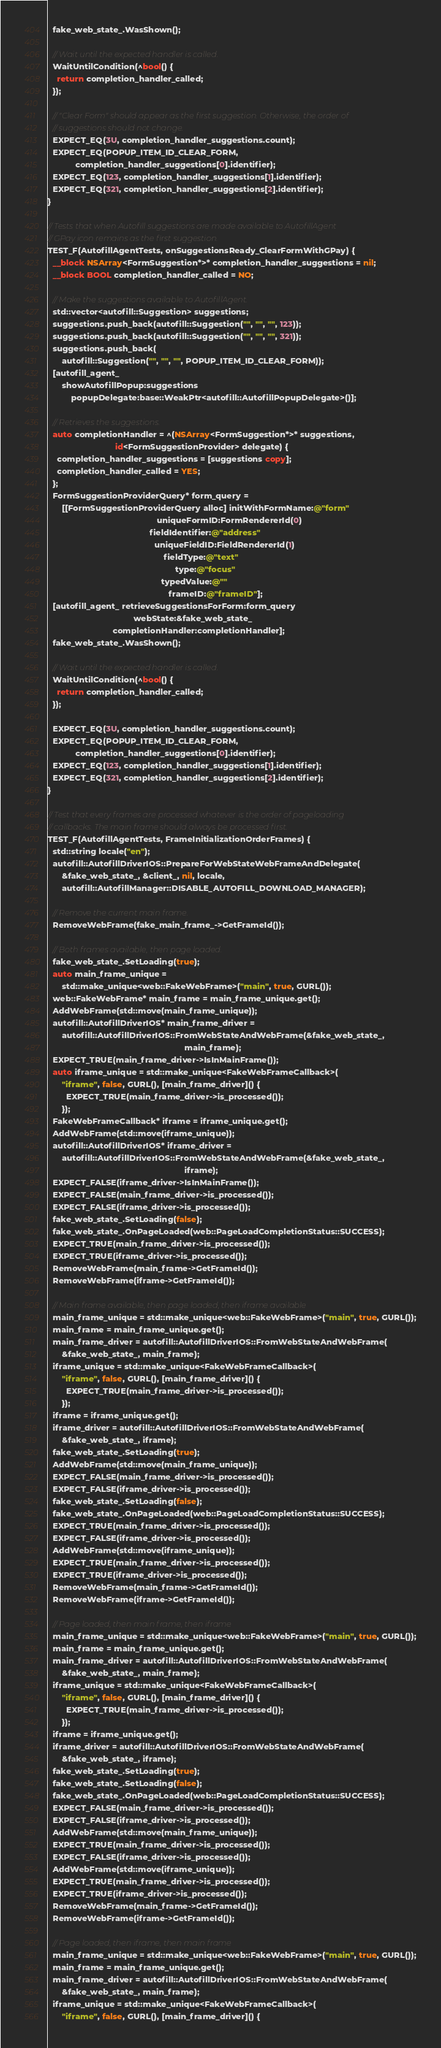<code> <loc_0><loc_0><loc_500><loc_500><_ObjectiveC_>  fake_web_state_.WasShown();

  // Wait until the expected handler is called.
  WaitUntilCondition(^bool() {
    return completion_handler_called;
  });

  // "Clear Form" should appear as the first suggestion. Otherwise, the order of
  // suggestions should not change.
  EXPECT_EQ(3U, completion_handler_suggestions.count);
  EXPECT_EQ(POPUP_ITEM_ID_CLEAR_FORM,
            completion_handler_suggestions[0].identifier);
  EXPECT_EQ(123, completion_handler_suggestions[1].identifier);
  EXPECT_EQ(321, completion_handler_suggestions[2].identifier);
}

// Tests that when Autofill suggestions are made available to AutofillAgent
// GPay icon remains as the first suggestion.
TEST_F(AutofillAgentTests, onSuggestionsReady_ClearFormWithGPay) {
  __block NSArray<FormSuggestion*>* completion_handler_suggestions = nil;
  __block BOOL completion_handler_called = NO;

  // Make the suggestions available to AutofillAgent.
  std::vector<autofill::Suggestion> suggestions;
  suggestions.push_back(autofill::Suggestion("", "", "", 123));
  suggestions.push_back(autofill::Suggestion("", "", "", 321));
  suggestions.push_back(
      autofill::Suggestion("", "", "", POPUP_ITEM_ID_CLEAR_FORM));
  [autofill_agent_
      showAutofillPopup:suggestions
          popupDelegate:base::WeakPtr<autofill::AutofillPopupDelegate>()];

  // Retrieves the suggestions.
  auto completionHandler = ^(NSArray<FormSuggestion*>* suggestions,
                             id<FormSuggestionProvider> delegate) {
    completion_handler_suggestions = [suggestions copy];
    completion_handler_called = YES;
  };
  FormSuggestionProviderQuery* form_query =
      [[FormSuggestionProviderQuery alloc] initWithFormName:@"form"
                                               uniqueFormID:FormRendererId(0)
                                            fieldIdentifier:@"address"
                                              uniqueFieldID:FieldRendererId(1)
                                                  fieldType:@"text"
                                                       type:@"focus"
                                                 typedValue:@""
                                                    frameID:@"frameID"];
  [autofill_agent_ retrieveSuggestionsForForm:form_query
                                     webState:&fake_web_state_
                            completionHandler:completionHandler];
  fake_web_state_.WasShown();

  // Wait until the expected handler is called.
  WaitUntilCondition(^bool() {
    return completion_handler_called;
  });

  EXPECT_EQ(3U, completion_handler_suggestions.count);
  EXPECT_EQ(POPUP_ITEM_ID_CLEAR_FORM,
            completion_handler_suggestions[0].identifier);
  EXPECT_EQ(123, completion_handler_suggestions[1].identifier);
  EXPECT_EQ(321, completion_handler_suggestions[2].identifier);
}

// Test that every frames are processed whatever is the order of pageloading
// callbacks. The main frame should always be processed first.
TEST_F(AutofillAgentTests, FrameInitializationOrderFrames) {
  std::string locale("en");
  autofill::AutofillDriverIOS::PrepareForWebStateWebFrameAndDelegate(
      &fake_web_state_, &client_, nil, locale,
      autofill::AutofillManager::DISABLE_AUTOFILL_DOWNLOAD_MANAGER);

  // Remove the current main frame.
  RemoveWebFrame(fake_main_frame_->GetFrameId());

  // Both frames available, then page loaded.
  fake_web_state_.SetLoading(true);
  auto main_frame_unique =
      std::make_unique<web::FakeWebFrame>("main", true, GURL());
  web::FakeWebFrame* main_frame = main_frame_unique.get();
  AddWebFrame(std::move(main_frame_unique));
  autofill::AutofillDriverIOS* main_frame_driver =
      autofill::AutofillDriverIOS::FromWebStateAndWebFrame(&fake_web_state_,
                                                           main_frame);
  EXPECT_TRUE(main_frame_driver->IsInMainFrame());
  auto iframe_unique = std::make_unique<FakeWebFrameCallback>(
      "iframe", false, GURL(), [main_frame_driver]() {
        EXPECT_TRUE(main_frame_driver->is_processed());
      });
  FakeWebFrameCallback* iframe = iframe_unique.get();
  AddWebFrame(std::move(iframe_unique));
  autofill::AutofillDriverIOS* iframe_driver =
      autofill::AutofillDriverIOS::FromWebStateAndWebFrame(&fake_web_state_,
                                                           iframe);
  EXPECT_FALSE(iframe_driver->IsInMainFrame());
  EXPECT_FALSE(main_frame_driver->is_processed());
  EXPECT_FALSE(iframe_driver->is_processed());
  fake_web_state_.SetLoading(false);
  fake_web_state_.OnPageLoaded(web::PageLoadCompletionStatus::SUCCESS);
  EXPECT_TRUE(main_frame_driver->is_processed());
  EXPECT_TRUE(iframe_driver->is_processed());
  RemoveWebFrame(main_frame->GetFrameId());
  RemoveWebFrame(iframe->GetFrameId());

  // Main frame available, then page loaded, then iframe available
  main_frame_unique = std::make_unique<web::FakeWebFrame>("main", true, GURL());
  main_frame = main_frame_unique.get();
  main_frame_driver = autofill::AutofillDriverIOS::FromWebStateAndWebFrame(
      &fake_web_state_, main_frame);
  iframe_unique = std::make_unique<FakeWebFrameCallback>(
      "iframe", false, GURL(), [main_frame_driver]() {
        EXPECT_TRUE(main_frame_driver->is_processed());
      });
  iframe = iframe_unique.get();
  iframe_driver = autofill::AutofillDriverIOS::FromWebStateAndWebFrame(
      &fake_web_state_, iframe);
  fake_web_state_.SetLoading(true);
  AddWebFrame(std::move(main_frame_unique));
  EXPECT_FALSE(main_frame_driver->is_processed());
  EXPECT_FALSE(iframe_driver->is_processed());
  fake_web_state_.SetLoading(false);
  fake_web_state_.OnPageLoaded(web::PageLoadCompletionStatus::SUCCESS);
  EXPECT_TRUE(main_frame_driver->is_processed());
  EXPECT_FALSE(iframe_driver->is_processed());
  AddWebFrame(std::move(iframe_unique));
  EXPECT_TRUE(main_frame_driver->is_processed());
  EXPECT_TRUE(iframe_driver->is_processed());
  RemoveWebFrame(main_frame->GetFrameId());
  RemoveWebFrame(iframe->GetFrameId());

  // Page loaded, then main frame, then iframe
  main_frame_unique = std::make_unique<web::FakeWebFrame>("main", true, GURL());
  main_frame = main_frame_unique.get();
  main_frame_driver = autofill::AutofillDriverIOS::FromWebStateAndWebFrame(
      &fake_web_state_, main_frame);
  iframe_unique = std::make_unique<FakeWebFrameCallback>(
      "iframe", false, GURL(), [main_frame_driver]() {
        EXPECT_TRUE(main_frame_driver->is_processed());
      });
  iframe = iframe_unique.get();
  iframe_driver = autofill::AutofillDriverIOS::FromWebStateAndWebFrame(
      &fake_web_state_, iframe);
  fake_web_state_.SetLoading(true);
  fake_web_state_.SetLoading(false);
  fake_web_state_.OnPageLoaded(web::PageLoadCompletionStatus::SUCCESS);
  EXPECT_FALSE(main_frame_driver->is_processed());
  EXPECT_FALSE(iframe_driver->is_processed());
  AddWebFrame(std::move(main_frame_unique));
  EXPECT_TRUE(main_frame_driver->is_processed());
  EXPECT_FALSE(iframe_driver->is_processed());
  AddWebFrame(std::move(iframe_unique));
  EXPECT_TRUE(main_frame_driver->is_processed());
  EXPECT_TRUE(iframe_driver->is_processed());
  RemoveWebFrame(main_frame->GetFrameId());
  RemoveWebFrame(iframe->GetFrameId());

  // Page loaded, then iframe, then main frame
  main_frame_unique = std::make_unique<web::FakeWebFrame>("main", true, GURL());
  main_frame = main_frame_unique.get();
  main_frame_driver = autofill::AutofillDriverIOS::FromWebStateAndWebFrame(
      &fake_web_state_, main_frame);
  iframe_unique = std::make_unique<FakeWebFrameCallback>(
      "iframe", false, GURL(), [main_frame_driver]() {</code> 